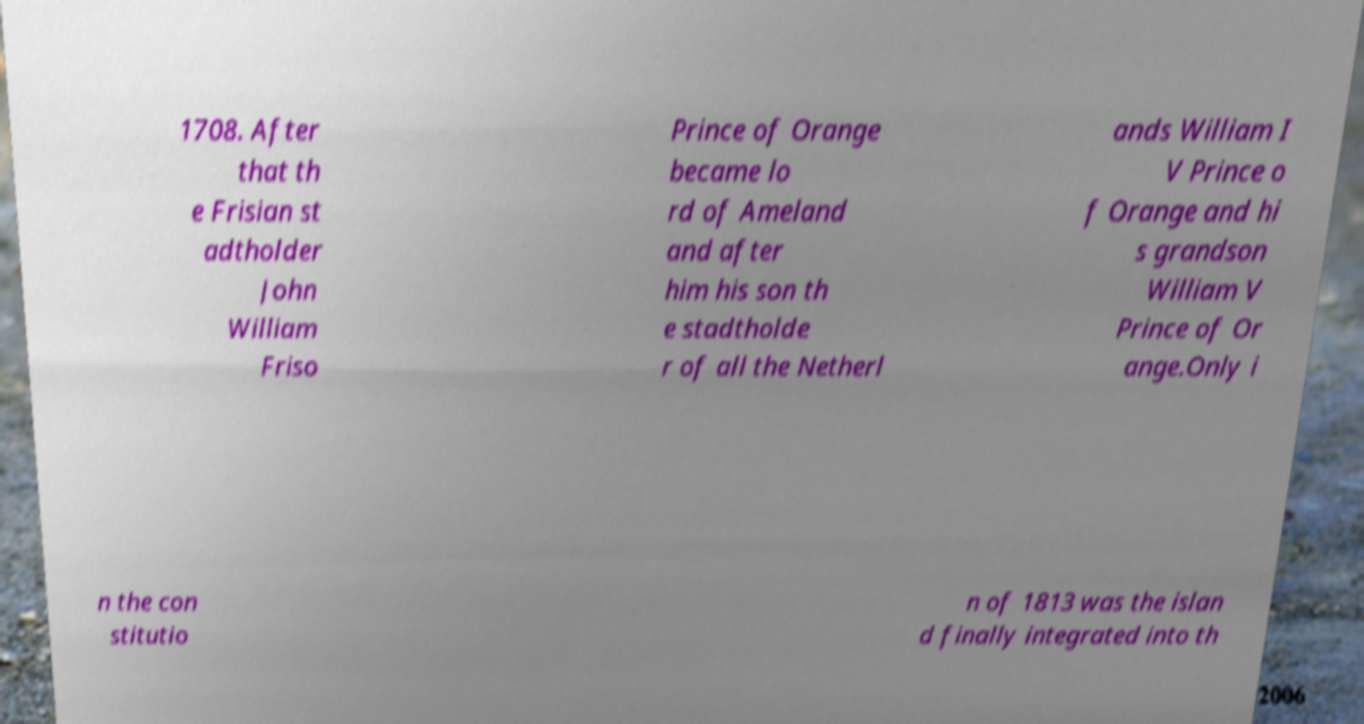What messages or text are displayed in this image? I need them in a readable, typed format. 1708. After that th e Frisian st adtholder John William Friso Prince of Orange became lo rd of Ameland and after him his son th e stadtholde r of all the Netherl ands William I V Prince o f Orange and hi s grandson William V Prince of Or ange.Only i n the con stitutio n of 1813 was the islan d finally integrated into th 